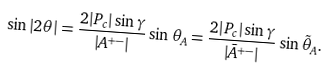<formula> <loc_0><loc_0><loc_500><loc_500>\sin | 2 \theta | = \frac { 2 | P _ { c } | \sin \gamma } { | A ^ { + - } | } \sin \theta _ { A } = \frac { 2 | P _ { c } | \sin \gamma } { | \bar { A } ^ { + - } | } \sin \tilde { \theta } _ { A } .</formula> 